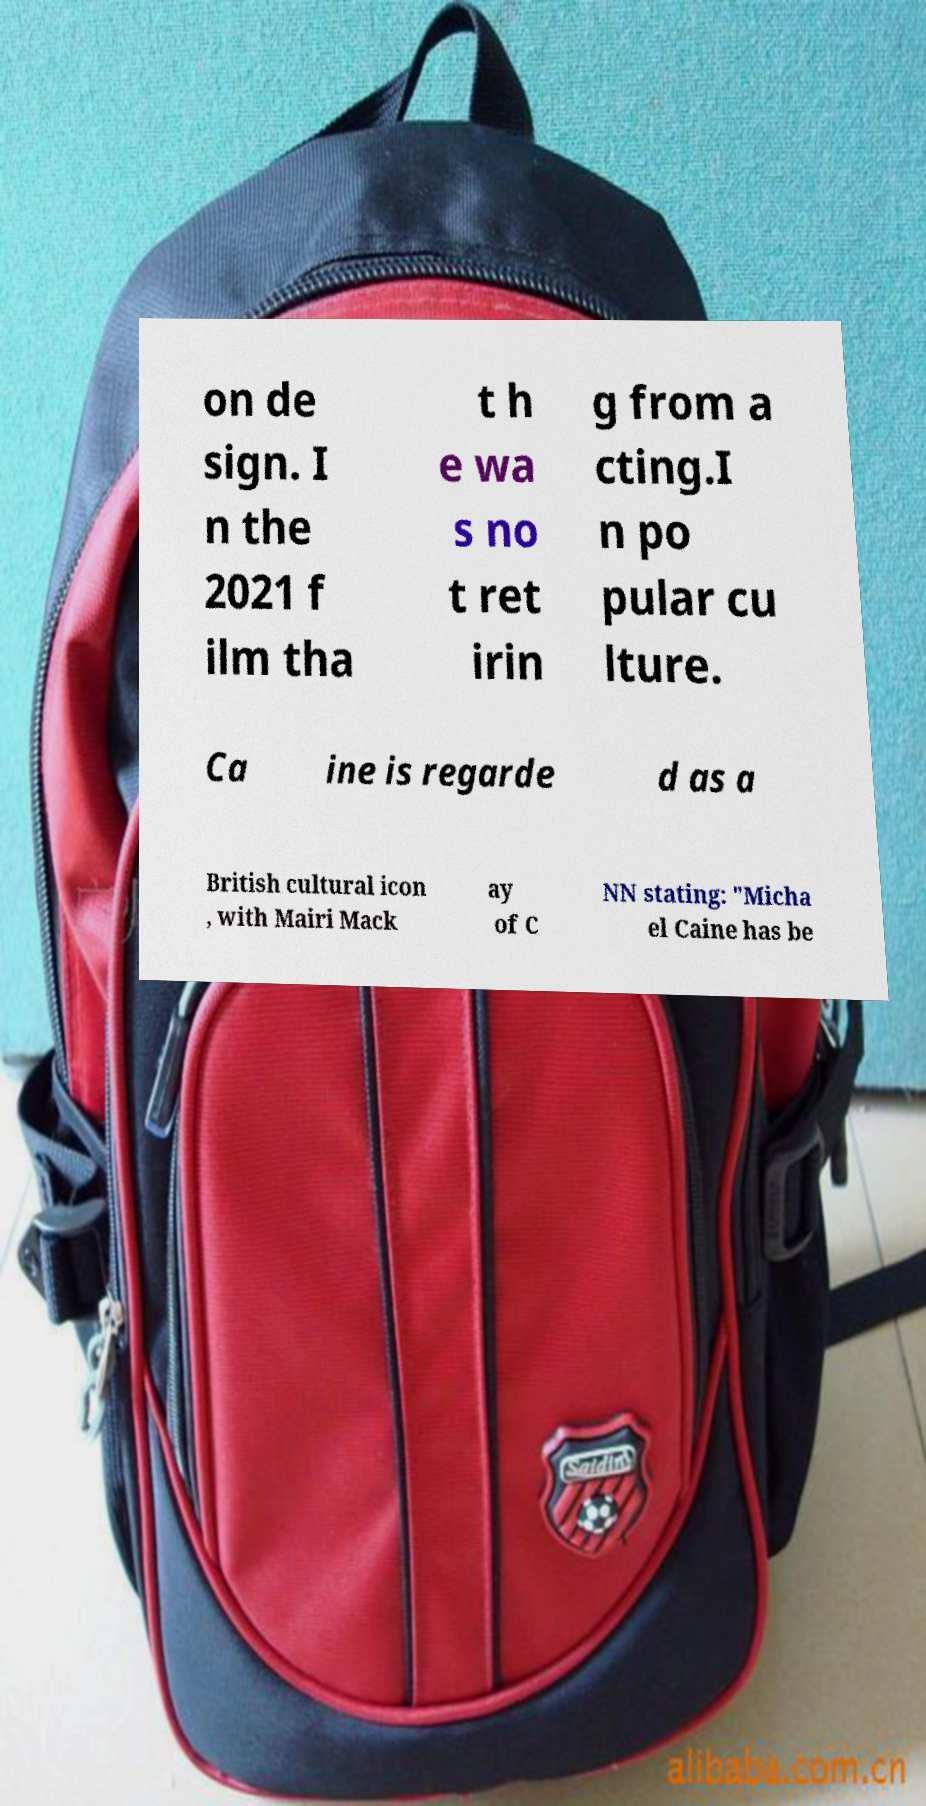For documentation purposes, I need the text within this image transcribed. Could you provide that? on de sign. I n the 2021 f ilm tha t h e wa s no t ret irin g from a cting.I n po pular cu lture. Ca ine is regarde d as a British cultural icon , with Mairi Mack ay of C NN stating: "Micha el Caine has be 